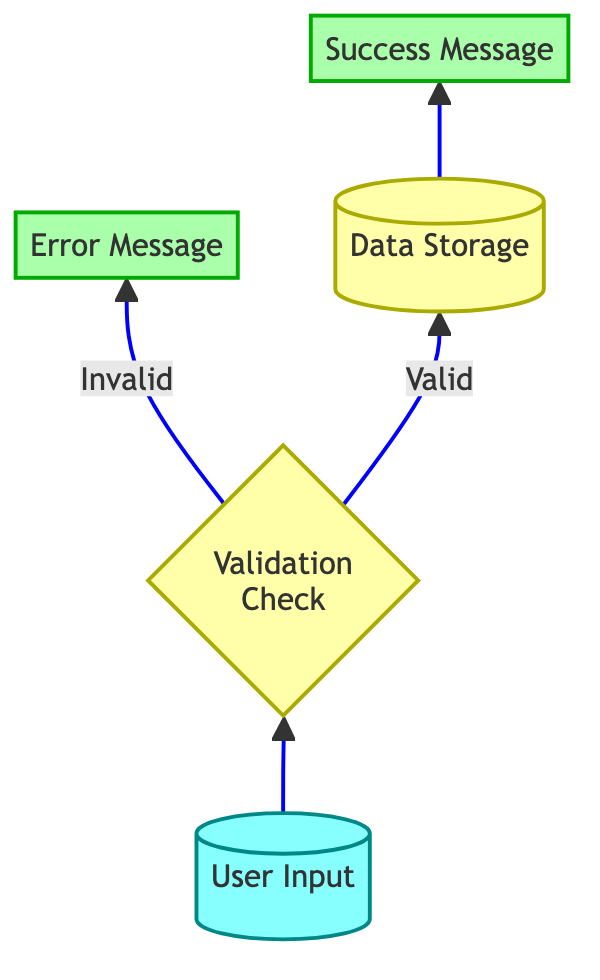What is the first node in the diagram? The first node in the diagram represents the starting point of the data entry process, labeled as "User Input".
Answer: User Input How many nodes are present in the diagram? Counting the distinct stages depicted in the diagram, there are a total of five nodes: User Input, Validation Check, Error Message, Data Storage, and Success Message.
Answer: 5 What action occurs if the validation check is invalid? If the validation check finds the user input to be invalid, the flow directs to the "Error Message" node, where feedback is given to the user.
Answer: Error Message What is the last node in the data flow? The final endpoint of the data flow, indicating successful completion of the process, is represented by the "Success Message" node.
Answer: Success Message What message is provided when the validation is successful? Upon successful validation, the flow proceeds to data storage, indicating the data has been successfully submitted, represented as "Success Message".
Answer: Success Message What is the relationship between the data storage and success message nodes? The data storage node directly feeds into the success message node, showcasing that once data is stored, a confirmation message is provided to the user.
Answer: Direct connection How does the process handle user input that fails validation? In the scenario where user input fails validation, the flow leads to an "Error Message" which communicates the validation issues to the user, and the process does not proceed to data storage.
Answer: Error Message Which node processes the data before it is stored? The "Validation Check" node is responsible for processing the data right before it is stored, verifying that it meets the required format and criteria.
Answer: Validation Check What type of messages are produced in this flow? The flow produces both an "Error Message" if the validation fails and a "Success Message" when data is successfully submitted, reflecting the results of the validation checks.
Answer: Error and Success Message What branch does the flow take after successful validation? After successful validation of the user input, the flow branches towards the "Data Storage" node to store the validated data.
Answer: Data Storage 